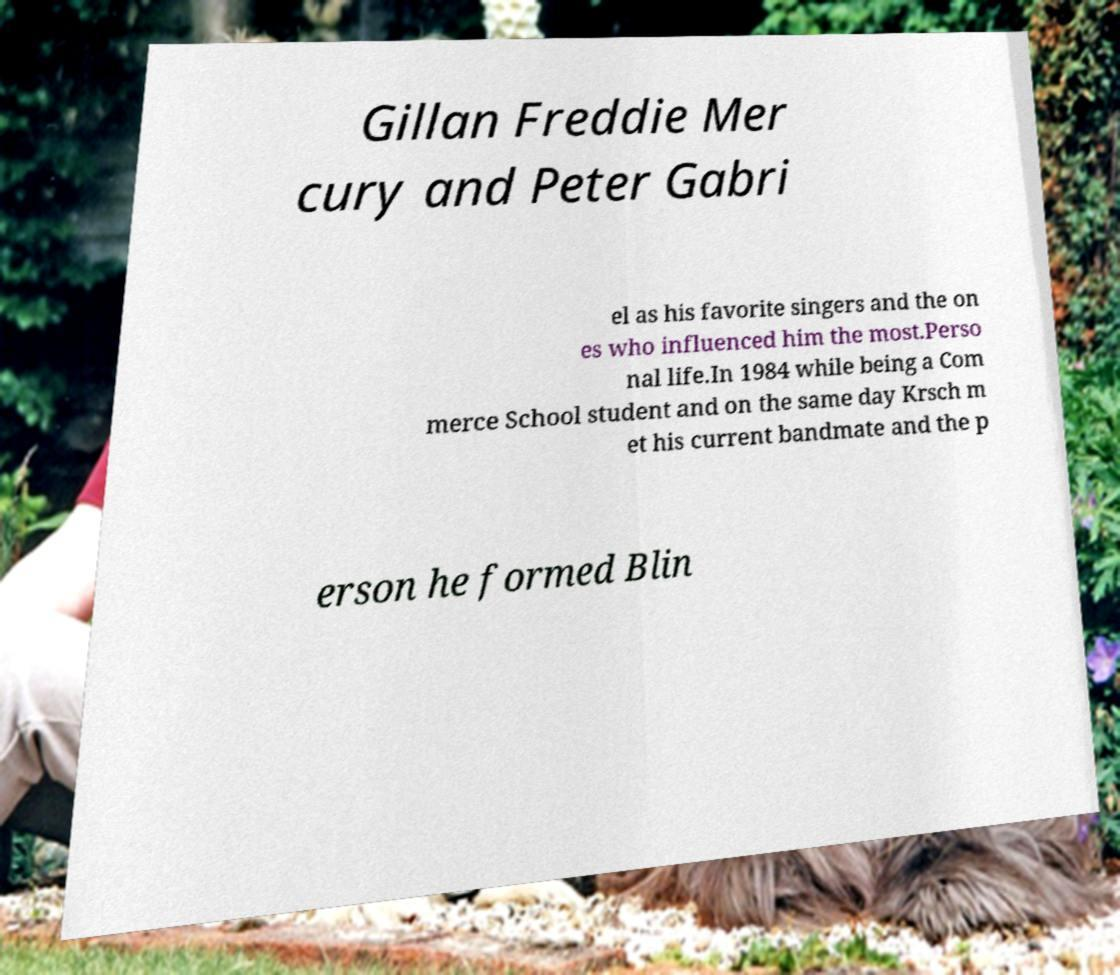For documentation purposes, I need the text within this image transcribed. Could you provide that? Gillan Freddie Mer cury and Peter Gabri el as his favorite singers and the on es who influenced him the most.Perso nal life.In 1984 while being a Com merce School student and on the same day Krsch m et his current bandmate and the p erson he formed Blin 